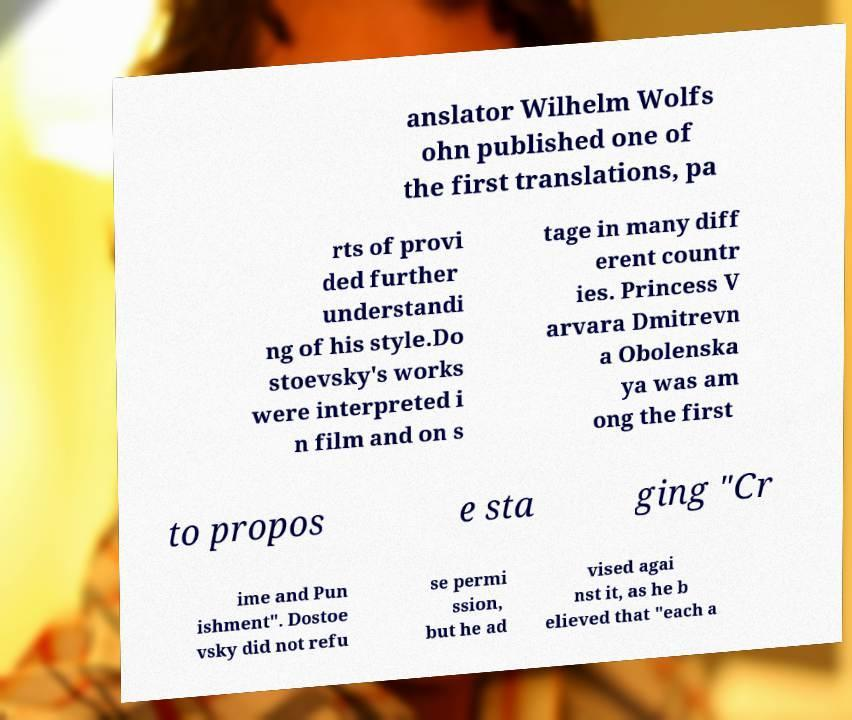There's text embedded in this image that I need extracted. Can you transcribe it verbatim? anslator Wilhelm Wolfs ohn published one of the first translations, pa rts of provi ded further understandi ng of his style.Do stoevsky's works were interpreted i n film and on s tage in many diff erent countr ies. Princess V arvara Dmitrevn a Obolenska ya was am ong the first to propos e sta ging "Cr ime and Pun ishment". Dostoe vsky did not refu se permi ssion, but he ad vised agai nst it, as he b elieved that "each a 